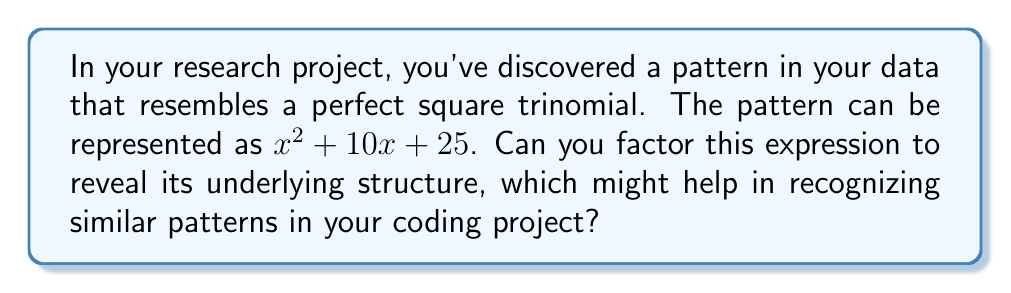Teach me how to tackle this problem. Let's approach this step-by-step:

1) A perfect square trinomial has the form $a^2 + 2ab + b^2$, where $a$ and $b$ are terms.

2) In our expression $x^2 + 10x + 25$, we can identify:
   - The first term is $x^2$, so $a = x$
   - The last term is 25, which is $5^2$, so $b = 5$

3) To confirm it's a perfect square trinomial, check the middle term:
   - It should be $2ab = 2(x)(5) = 10x$, which matches our middle term

4) Now we can factor it as $(a + b)^2$:
   $x^2 + 10x + 25 = (x + 5)^2$

5) This factored form reveals the underlying pattern: it's the square of a binomial.

In coding, recognizing this pattern could help you identify perfect square structures in your data or algorithms, potentially leading to optimizations or insights in your research project.
Answer: $(x + 5)^2$ 